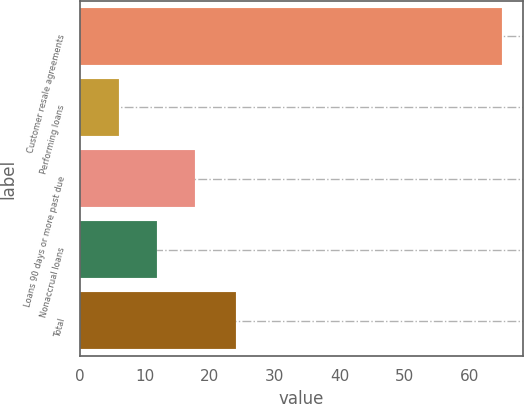Convert chart to OTSL. <chart><loc_0><loc_0><loc_500><loc_500><bar_chart><fcel>Customer resale agreements<fcel>Performing loans<fcel>Loans 90 days or more past due<fcel>Nonaccrual loans<fcel>Total<nl><fcel>65<fcel>6<fcel>17.8<fcel>11.9<fcel>24<nl></chart> 